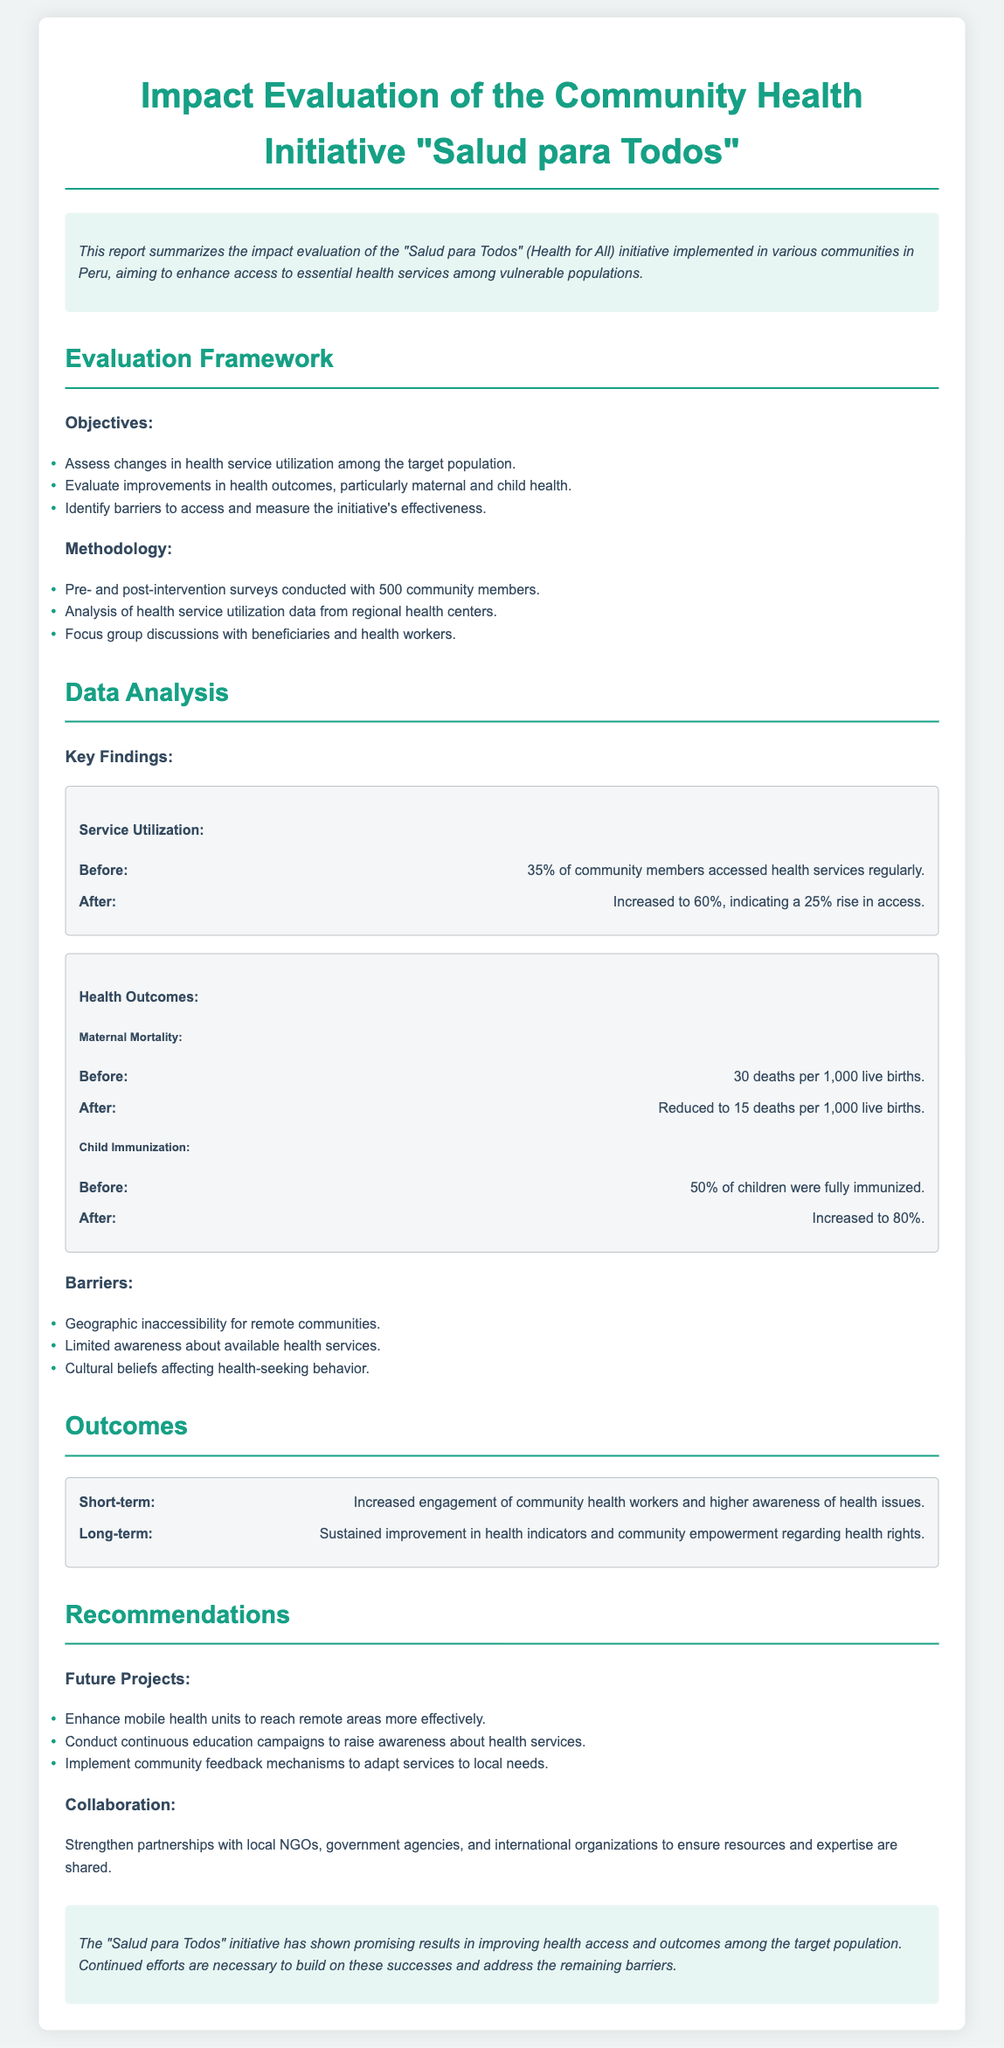What is the name of the community health initiative? The name of the initiative is mentioned in the title of the document, which is "Salud para Todos".
Answer: Salud para Todos What was the sample size of the pre- and post-intervention surveys? The sample size of the surveys is provided in the methodology section, where it states that 500 community members were surveyed.
Answer: 500 What was the percentage increase in health service utilization? The increase in health service utilization is calculated as 60% - 35% before and after the initiative, which is a 25% rise.
Answer: 25% What was the maternal mortality rate before the initiative? The maternal mortality rate before the initiative is directly stated in the document within the health outcomes section as 30 deaths per 1,000 live births.
Answer: 30 deaths per 1,000 live births What recommendation is made for reaching remote areas? The document includes recommendations for future projects, one of which is to enhance mobile health units to effectively reach remote areas.
Answer: Enhance mobile health units What was the percentage of fully immunized children after the initiative? The health outcomes section shows that the percentage of fully immunized children increased to 80% after the initiative.
Answer: 80% What barrier was identified related to community awareness? The report lists several barriers, one of which is that there was limited awareness about available health services among the community.
Answer: Limited awareness What is a long-term outcome expected from the initiative? The document specifies that a long-term outcome includes sustained improvement in health indicators and community empowerment regarding health rights.
Answer: Sustained improvement in health indicators What type of partnerships does the document recommend strengthening? The recommendations section mentions strengthening partnerships with local NGOs, government agencies, and international organizations.
Answer: Local NGOs and government agencies 